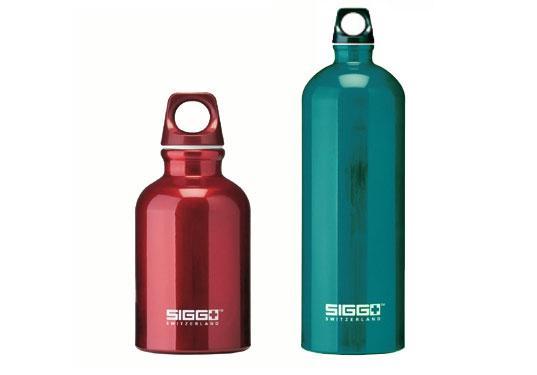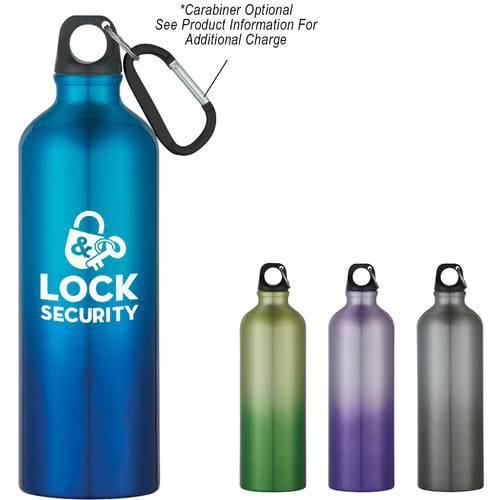The first image is the image on the left, the second image is the image on the right. Analyze the images presented: Is the assertion "There are seven bottles." valid? Answer yes or no. No. 